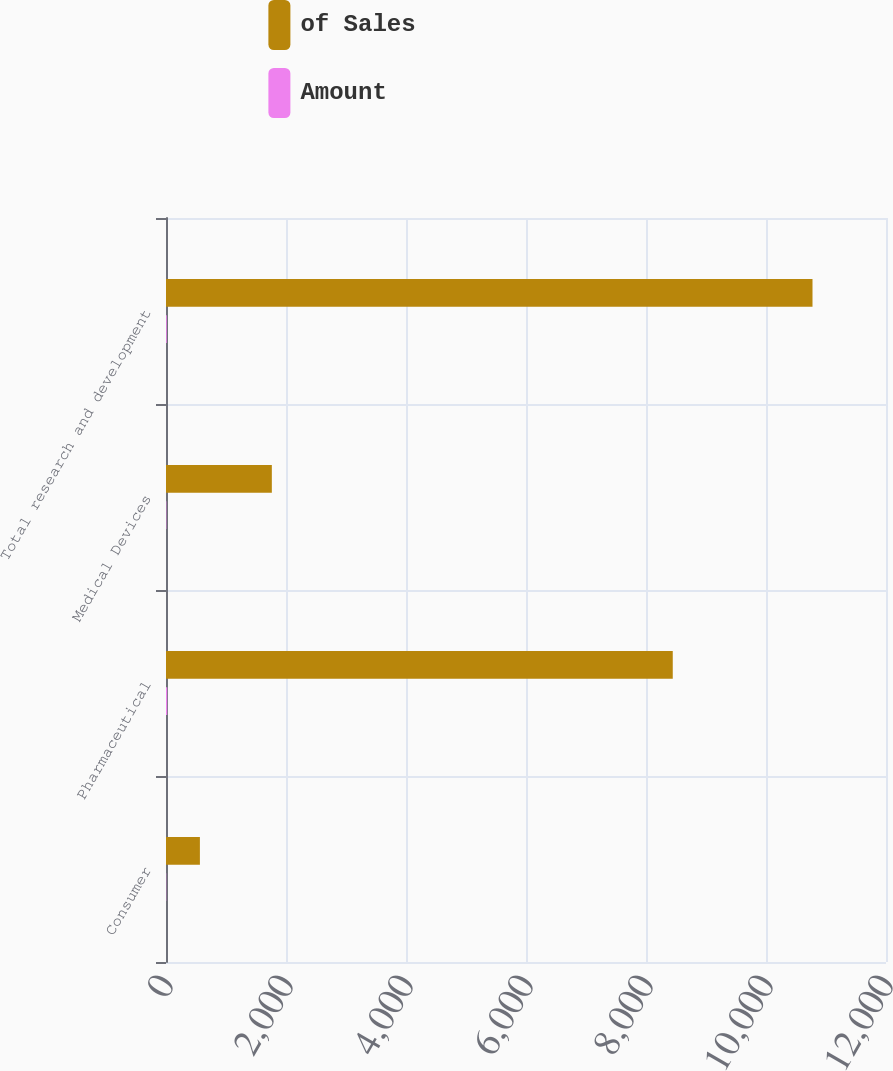<chart> <loc_0><loc_0><loc_500><loc_500><stacked_bar_chart><ecel><fcel>Consumer<fcel>Pharmaceutical<fcel>Medical Devices<fcel>Total research and development<nl><fcel>of Sales<fcel>565<fcel>8446<fcel>1764<fcel>10775<nl><fcel>Amount<fcel>4.1<fcel>20.7<fcel>6.5<fcel>13.2<nl></chart> 